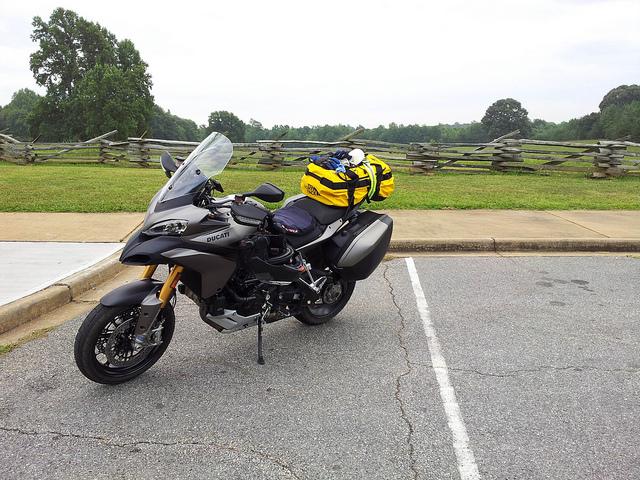What color is the luggage bag?
Give a very brief answer. Yellow. Is this a moped?
Be succinct. No. What is across the road in the fenced in area?
Keep it brief. Trees. Is this photo taken in a big city?
Keep it brief. No. 